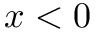<formula> <loc_0><loc_0><loc_500><loc_500>x < 0</formula> 